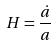<formula> <loc_0><loc_0><loc_500><loc_500>H = \frac { \dot { a } } { a }</formula> 